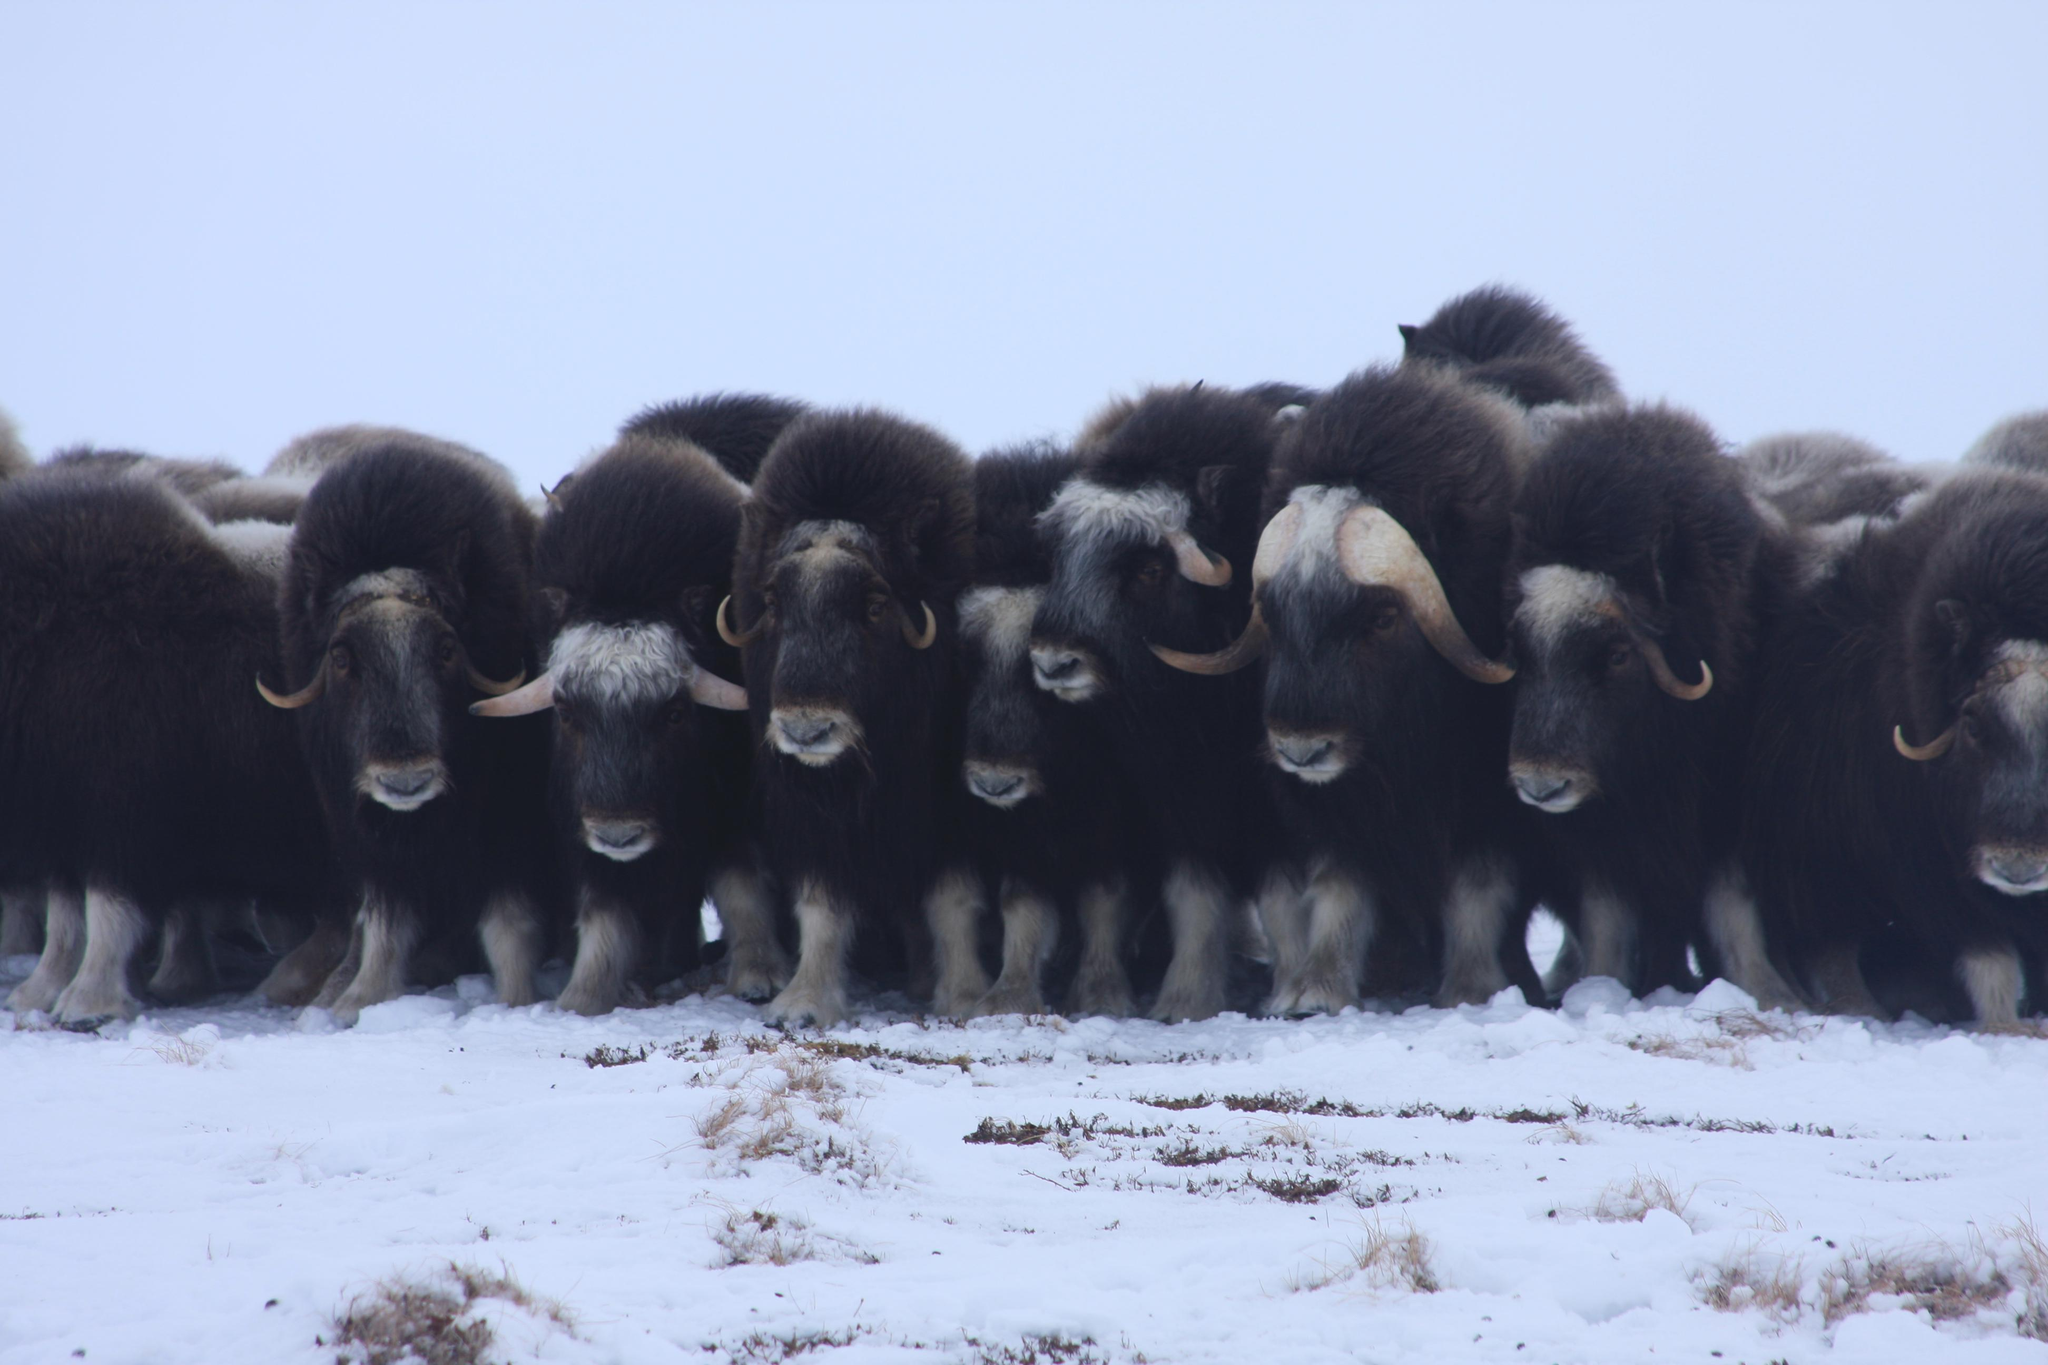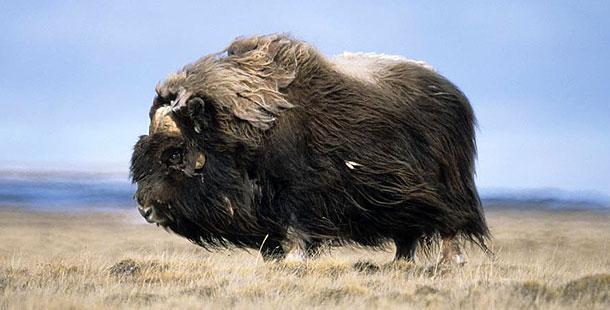The first image is the image on the left, the second image is the image on the right. For the images shown, is this caption "There are no more than three yaks in the left image." true? Answer yes or no. No. 